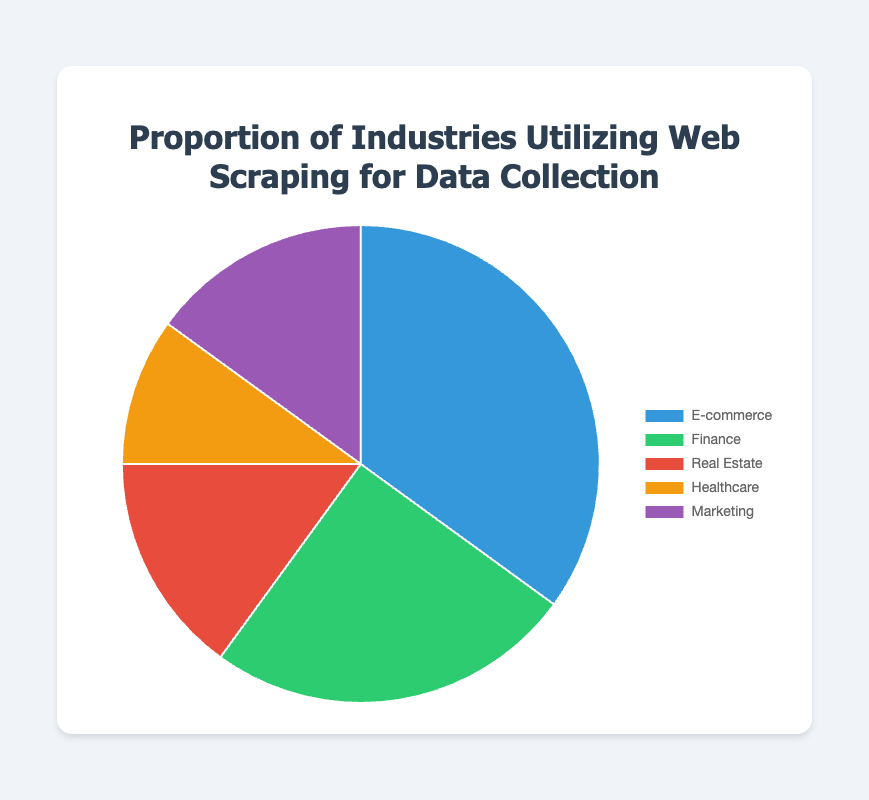Which industry has the highest proportion of utilizing web scraping for data collection? From the pie chart, the largest segment represents E-commerce at 35%. This indicates that E-commerce has the highest proportion.
Answer: E-commerce Which industries have the same proportion of utilizing web scraping for data collection? From the pie chart, Real Estate and Marketing both have a 15% share. This indicates that these two industries have the same proportion.
Answer: Real Estate, Marketing How much greater is the proportion of the E-commerce industry compared to the Healthcare industry? The percentage for E-commerce is 35% and for Healthcare is 10%. The difference is calculated as 35 - 10, which equals 25.
Answer: 25% What is the summed proportion of the Finance and Healthcare industries? The Finance industry is 25% and the Healthcare industry is 10%. Summing them gives 25 + 10 = 35.
Answer: 35% What is the averaged proportion of all the industries listed? Add up all proportions: 35 (E-commerce) + 25 (Finance) + 15 (Real Estate) + 10 (Healthcare) + 15 (Marketing) = 100. Divide by the number of industries (5): 100 / 5 = 20.
Answer: 20% Which segment is represented by the green color in the pie chart? From visual inspection of the pie chart, the green segment likely represents Finance, as it stands out distinctly and matches the relative position described.
Answer: Finance Which is smaller in proportion: Real Estate or Healthcare? From the pie chart, Real Estate has 15% whereas Healthcare has 10%. Therefore, Healthcare has a smaller proportion.
Answer: Healthcare If Marketing increased its proportion to 20%, by how much would the summed total proportion of Marketing and Real Estate change? Originally, Marketing and Real Estate both are 15%. If Marketing increases to 20%, the change in Marketing is 20 - 15 = 5. Summing Real Estate (15) and new Marketing (20) gives 15 + 20 = 35. The original total was 15 + 15 = 30. Therefore, the increase is 35 - 30 = 5.
Answer: 5% If the proportion for Healthcare was doubled, what would be its new proportion? The current proportion for Healthcare is 10%. Doubling this would give 10 * 2 = 20%.
Answer: 20% Which industry has the smallest proportion of utilizing web scraping for data collection? According to the pie chart, Healthcare has the smallest proportion at 10%.
Answer: Healthcare 